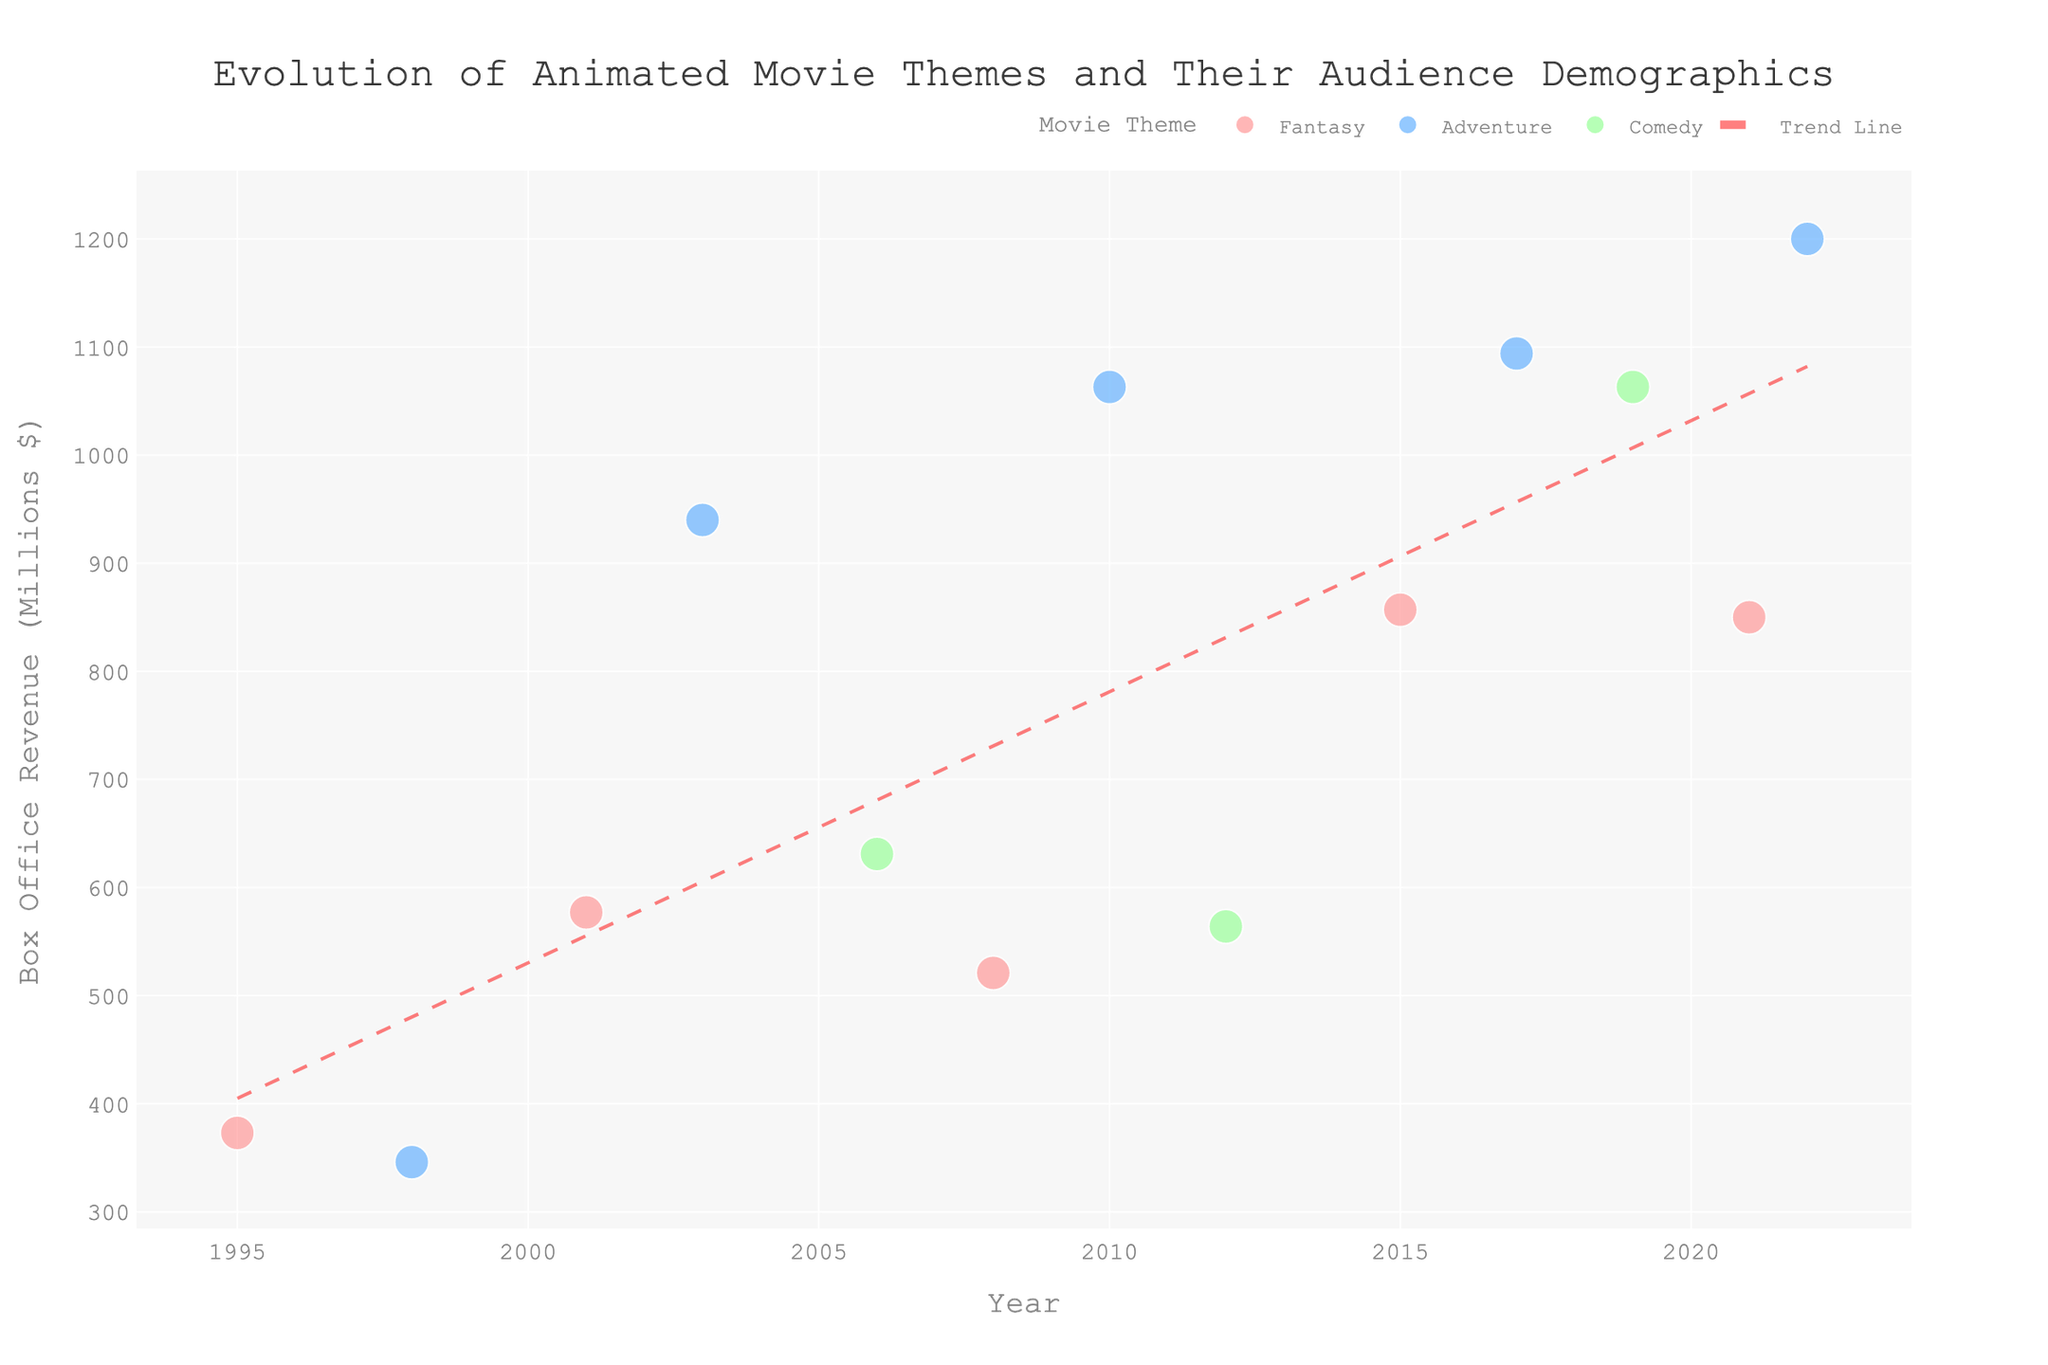What is the title of the plot? The title of the plot can be found at the top of the figure. It reads "Evolution of Animated Movie Themes and Their Audience Demographics"
Answer: Evolution of Animated Movie Themes and Their Audience Demographics How many different animated movie themes are represented in the plot? By looking at the color legend, we can see three distinct colors representing different themes. These themes are 'Fantasy', 'Adventure', and 'Comedy'.
Answer: 3 What data is on the x-axis and y-axis? The x-axis title can be found along the bottom horizontal line, labeled "Year". The y-axis title is along the vertical line on the left, labeled "Box Office Revenue (Millions $)".
Answer: Year, Box Office Revenue (Millions $) Which year had the highest box office revenue? Looking at the scatter points' vertical positions, we find the highest point on the y-axis. Here, we see the year labeled next to it is 2022, with a box office revenue of 1200 millions.
Answer: 2022 What is the median age of the audience for the movie theme with the highest box office revenue in 2010? First, find the scatter point for 2010, and look at its associated movie theme and median audience age, which is an Adventure movie with a median age of 13.
Answer: 13 Between 1995 and 2022, which movie theme showed the highest average box office revenue based on the scatter plot? Identify each theme's corresponding points and calculate their average box office revenues. 'Adventure' movies, depicted by blue points, have the highest average revenue, as they consistently appear higher on the y-axis.
Answer: Adventure Has there been a general trend in box office revenue over the years? Observing the trend line that has been added to the plot, we notice that it slopes upwards, indicating an overall increase in box office revenue over the years.
Answer: Increase Which animated movie theme appears to target the youngest median audience age? Looking at the scatter points and their varying sizes, and checking the color map, 'Fantasy' movies consistently have smaller-sized points, showing they target the youngest audiences.
Answer: Fantasy Which two themes had the highest box office revenue in 2019 and 2021, and what were their revenues? Find the points corresponding to the years 2019 and 2021. In 2019, 'Comedy' had the highest revenue (1063). In 2021, 'Fantasy' had the highest revenue (850).
Answer: Comedy: 1063, Fantasy: 850 